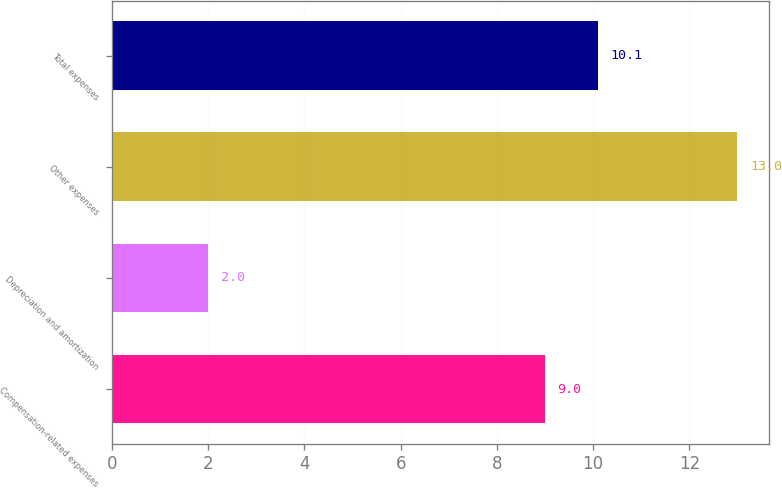Convert chart to OTSL. <chart><loc_0><loc_0><loc_500><loc_500><bar_chart><fcel>Compensation-related expenses<fcel>Depreciation and amortization<fcel>Other expenses<fcel>Total expenses<nl><fcel>9<fcel>2<fcel>13<fcel>10.1<nl></chart> 